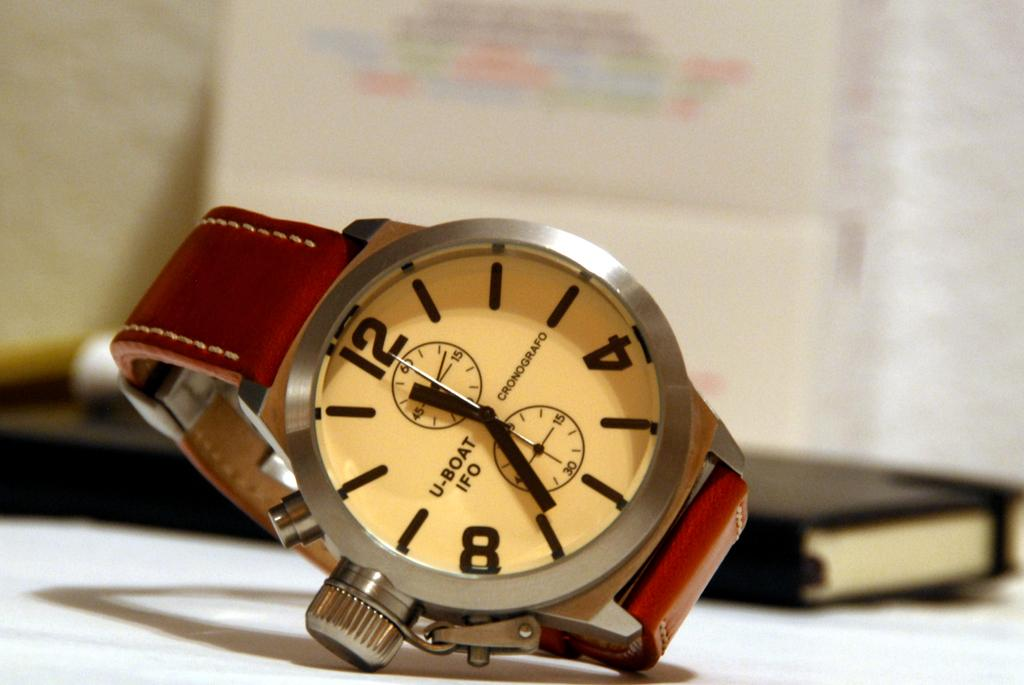<image>
Provide a brief description of the given image. A U-Boat IFO watch has the time of 11:34. 